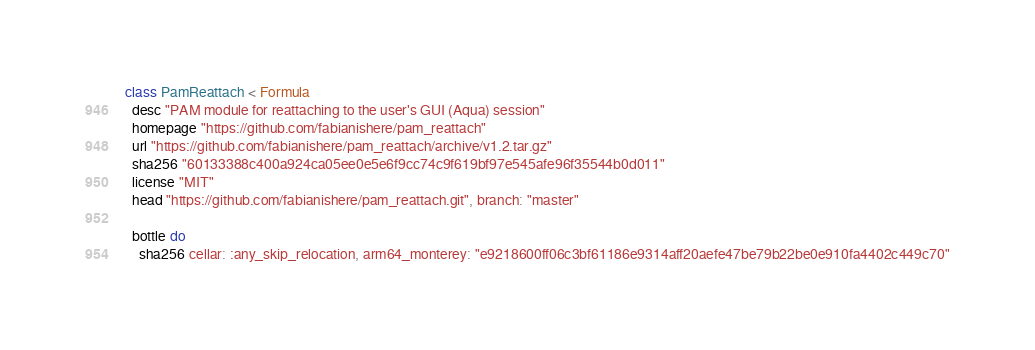Convert code to text. <code><loc_0><loc_0><loc_500><loc_500><_Ruby_>class PamReattach < Formula
  desc "PAM module for reattaching to the user's GUI (Aqua) session"
  homepage "https://github.com/fabianishere/pam_reattach"
  url "https://github.com/fabianishere/pam_reattach/archive/v1.2.tar.gz"
  sha256 "60133388c400a924ca05ee0e5e6f9cc74c9f619bf97e545afe96f35544b0d011"
  license "MIT"
  head "https://github.com/fabianishere/pam_reattach.git", branch: "master"

  bottle do
    sha256 cellar: :any_skip_relocation, arm64_monterey: "e9218600ff06c3bf61186e9314aff20aefe47be79b22be0e910fa4402c449c70"</code> 